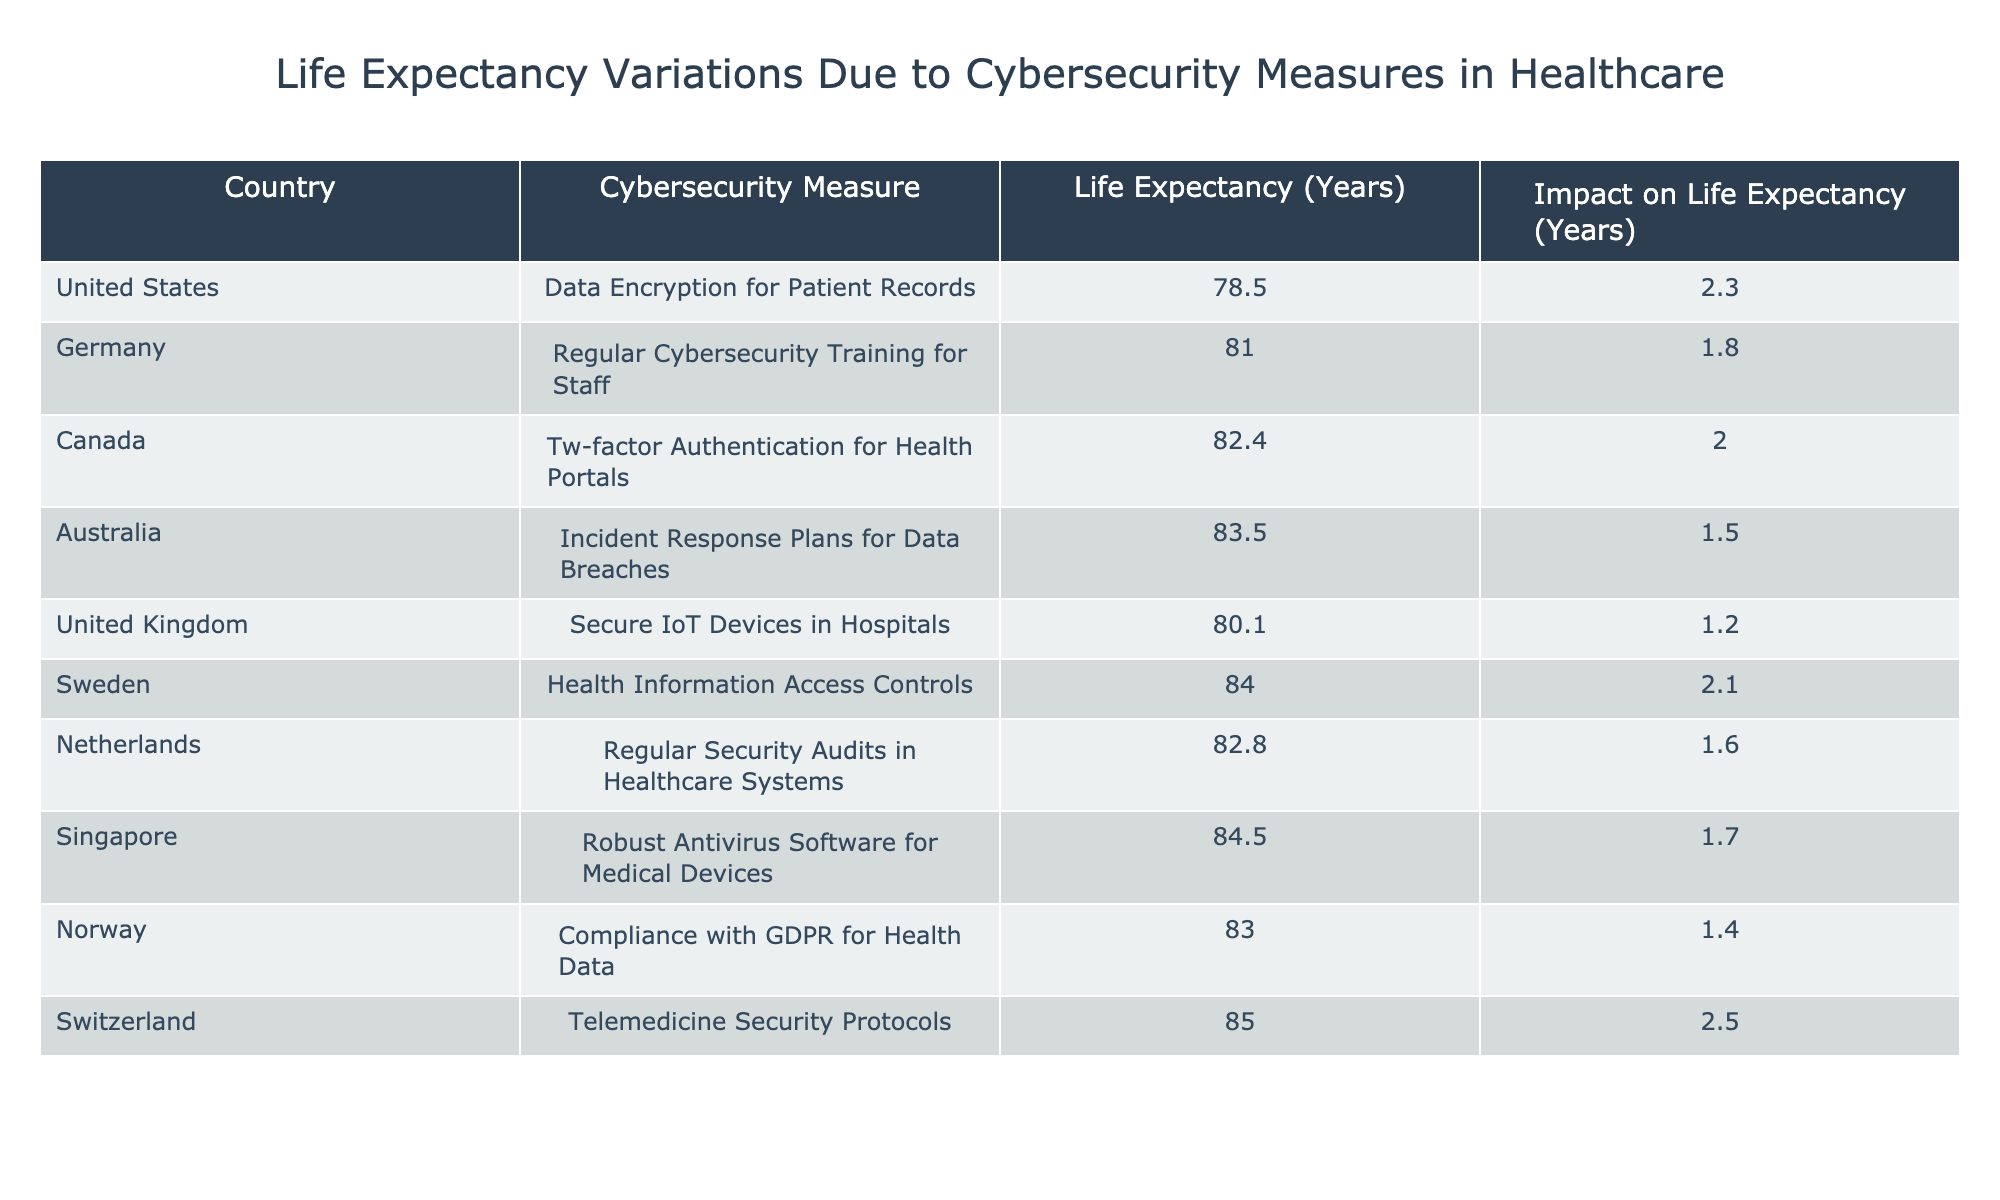What is the life expectancy in Canada? In the table, Canada is listed with a life expectancy of 82.4 years. This value is located in the "Life Expectancy (Years)" column corresponding to Canada.
Answer: 82.4 Which cybersecurity measure has the greatest impact on life expectancy? The maximum impact on life expectancy is 2.5 years, associated with Switzerland's Telemedicine Security Protocols. This information is found in the "Impact on Life Expectancy (Years)" column.
Answer: 2.5 Is the life expectancy higher in Australia or Germany? Australia has a life expectancy of 83.5 years, while Germany has 81.0 years. Comparing these two values, Australia has a higher life expectancy than Germany.
Answer: Yes What is the average life expectancy of the countries listed? To find the average, add all life expectancies: 78.5 + 81.0 + 82.4 + 83.5 + 80.1 + 84.0 + 82.8 + 84.5 + 83.0 + 85.0 = 831.8. Then, divide by the number of countries, which is 10: 831.8 / 10 = 83.18.
Answer: 83.18 Which two countries have the lowest life expectancy values listed in the table? Scanning through the "Life Expectancy (Years)" column, the lowest values are from the United States at 78.5 and Germany at 81.0. These two countries represent the lowest life expectancy in the table.
Answer: United States, Germany Does implementing robust antivirus software for medical devices improve life expectancy? Yes, according to the table, Singapore’s implementation of robust antivirus software for medical devices correlates with a life expectancy of 84.5 years, an impact of 1.7 years.
Answer: Yes How much does Sweden's health information access controls improve life expectancy compared to the life expectancy in the United States? Sweden's life expectancy is 84.0 years, and the United States is 78.5 years. The difference in life expectancy is 84.0 - 78.5 = 5.5 years. This shows that Sweden's measure improves life expectancy compared to the U.S. by this amount.
Answer: 5.5 Which country has a higher life expectancy, Norway or Canada? Norway has a life expectancy of 83.0 years, whereas Canada has 82.4 years. Comparing these values, Norway has a higher life expectancy than Canada.
Answer: Yes What is the total impact of all identified cybersecurity measures on life expectancy in the countries listed? To get the total impact, sum up all impact values: 2.3 + 1.8 + 2.0 + 1.5 + 1.2 + 2.1 + 1.6 + 1.7 + 1.4 + 2.5 = 17.1 years. Thus, the total impact is 17.1 years combined across all cybersecurity measures.
Answer: 17.1 